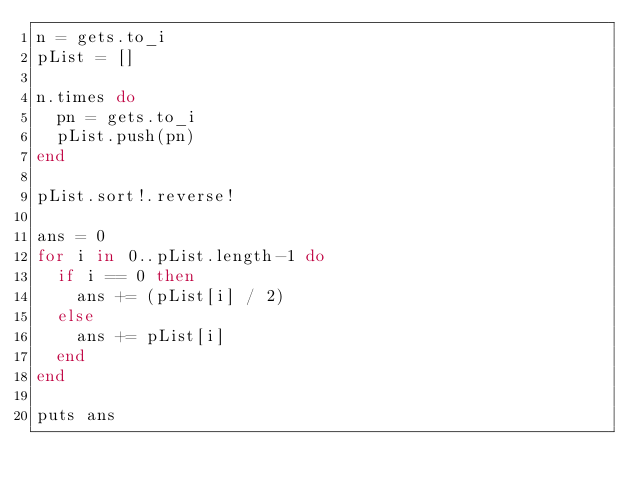Convert code to text. <code><loc_0><loc_0><loc_500><loc_500><_Ruby_>n = gets.to_i
pList = []

n.times do
  pn = gets.to_i
  pList.push(pn)
end

pList.sort!.reverse!

ans = 0
for i in 0..pList.length-1 do
  if i == 0 then
    ans += (pList[i] / 2)
  else
    ans += pList[i]
  end
end

puts ans
</code> 